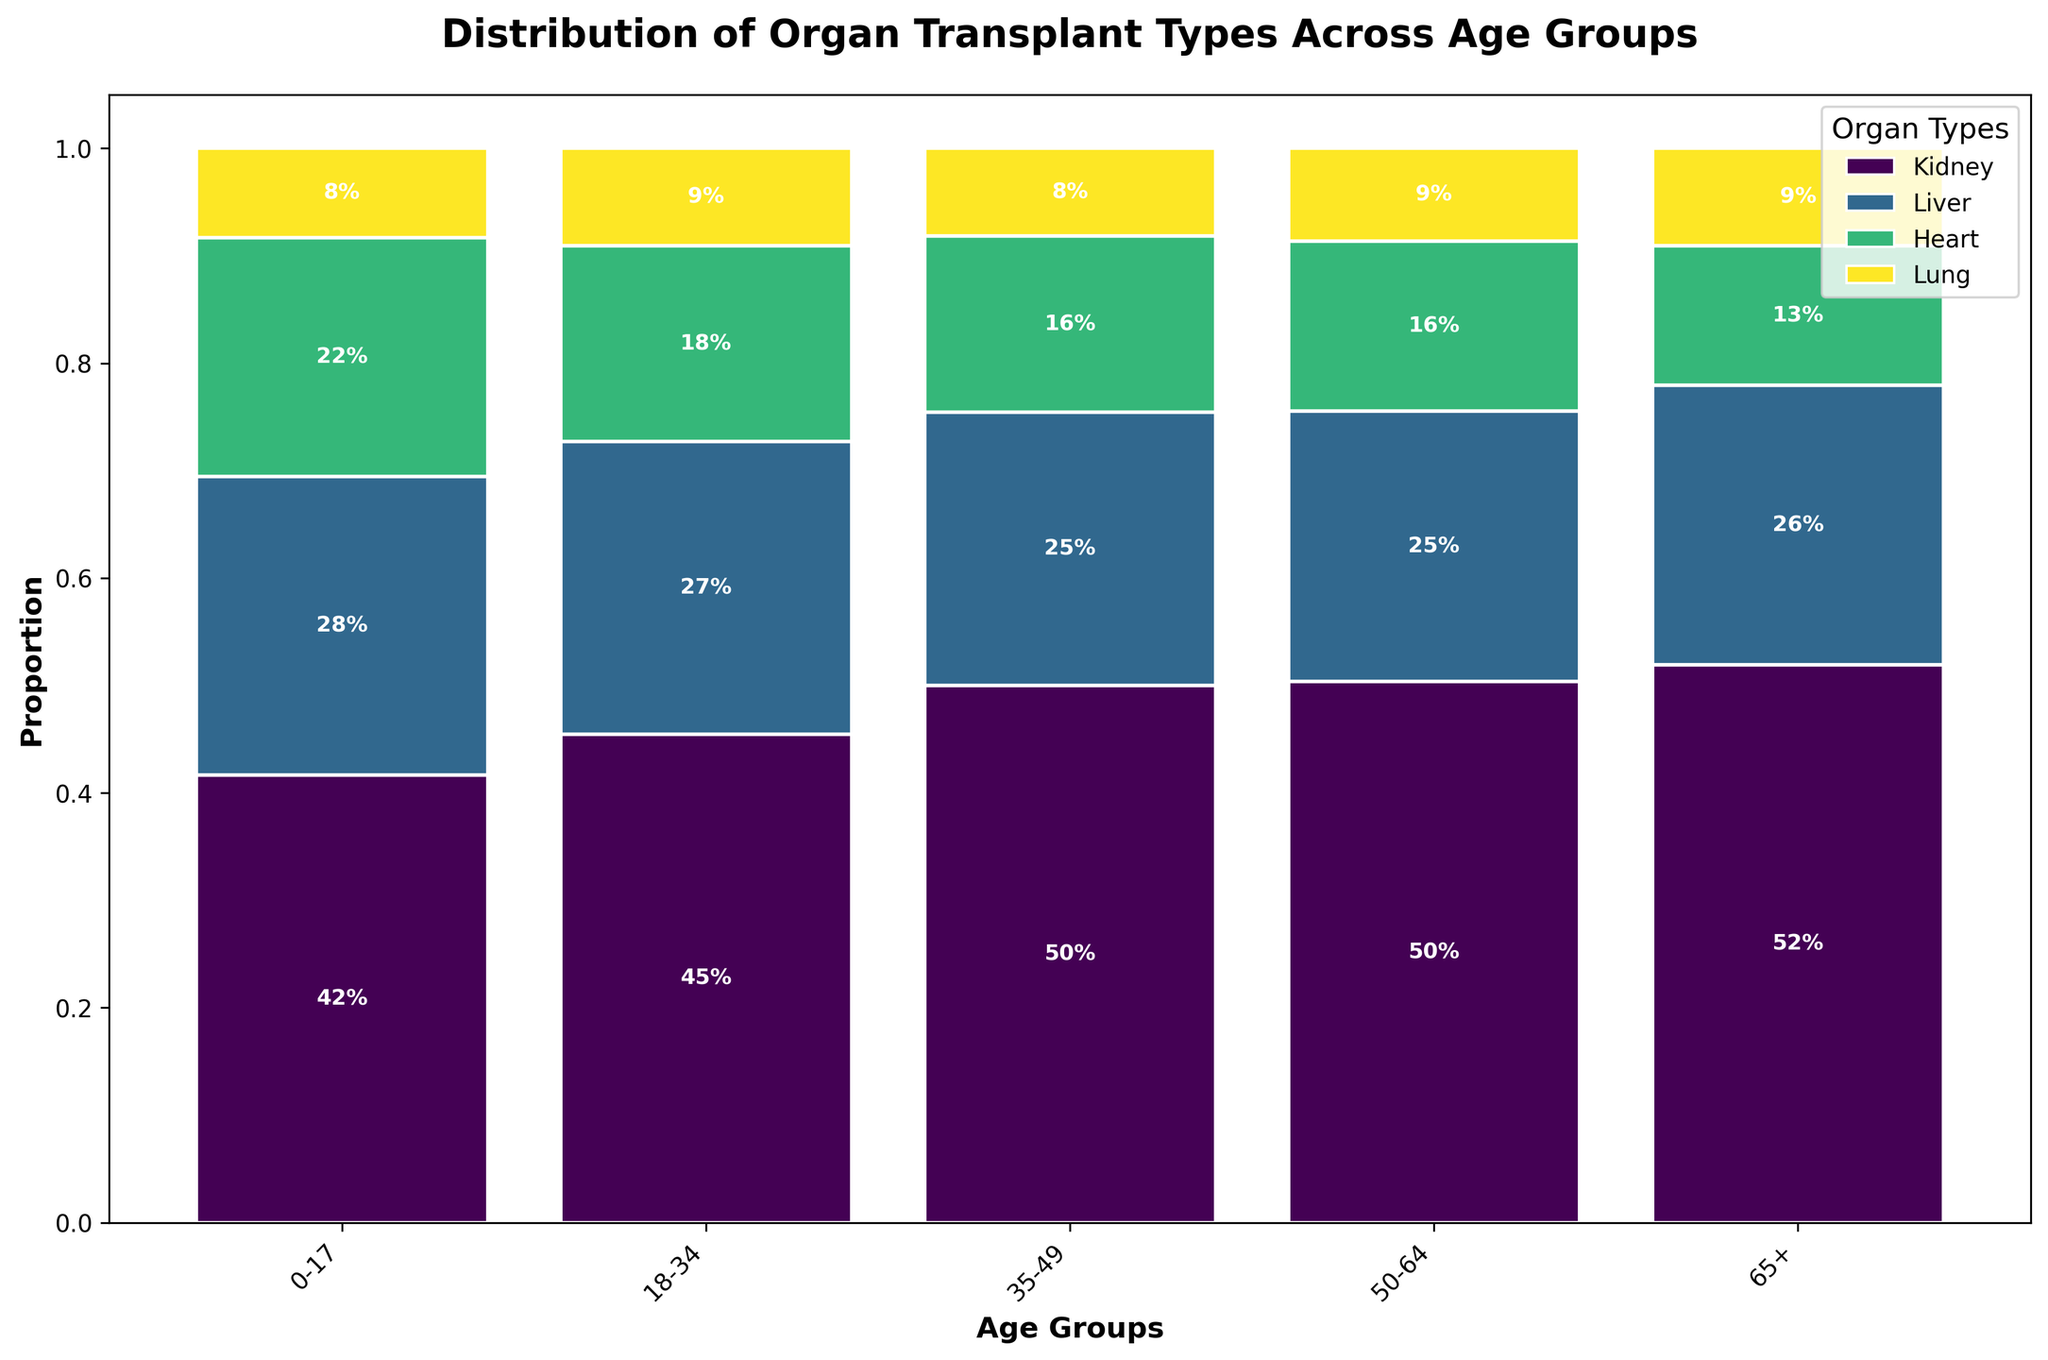What is the title of the figure? The title is displayed at the top of the plot and summarizes the subject of the figure. It states, "Distribution of Organ Transplant Types Across Age Groups".
Answer: Distribution of Organ Transplant Types Across Age Groups Which age group has the highest proportion of kidney transplants? Look at the bar heights for the kidney transplants across different age groups. The tallest segment for kidney transplants corresponds to the "50-64" age group.
Answer: 50-64 Which organ has the smallest proportion of transplants in the "0-17" age group? In the "0-17" column, check the height of various segments. The smallest segment corresponds to lung transplants.
Answer: Lung How does the proportion of liver transplants change between the "18-34" and "35-49" age groups? Observe the height of the liver segment in "18-34" and compare it to "35-49". The height increases from "18-34" to "35-49".
Answer: Increases Which two age groups have the closest proportions of heart transplants? Compare the heights of the heart segments across different age groups. "0-17" and "65+" have closely related proportions of heart transplants.
Answer: 0-17 and 65+ Among lung transplants, which age group has the highest proportion? Check the segment heights for lung transplants across all age groups. The highest segment is in the "50-64" age group.
Answer: 50-64 What is the combined proportion of liver and heart transplants in the "50-64" age group? Sum the proportions of liver and heart in the "50-64" column. The liver proportion is 0.35 and the heart proportion is 0.22. So, 0.35 + 0.22 = 0.57.
Answer: 0.57 Which organ type shows the most significant decline in proportion from the "50-64" to the "65+" age group? Compare the segment heights between "50-64" and "65+" for each organ type. The kidney transplants show the most significant decline.
Answer: Kidney What percentage of the transplants in the "35-49" age group are liver transplants? Refer to the label of liver transplants in the "35-49" column, which shows the proportion. It is 28%, meaning 28% of the transplants are liver transplants.
Answer: 28% Comparing the "0-17" and "18-34" age groups, which has a higher combined proportion of kidney and liver transplants? Add up the proportions of kidney and liver transplants for both groups. For "0-17": 0.15 (kidney) + 0.1 (liver) = 0.25. For "18-34": 0.3 (kidney) + 0.18 (liver) = 0.48. The "18-34" age group has a higher combined proportion (0.48 vs. 0.25).
Answer: 18-34 